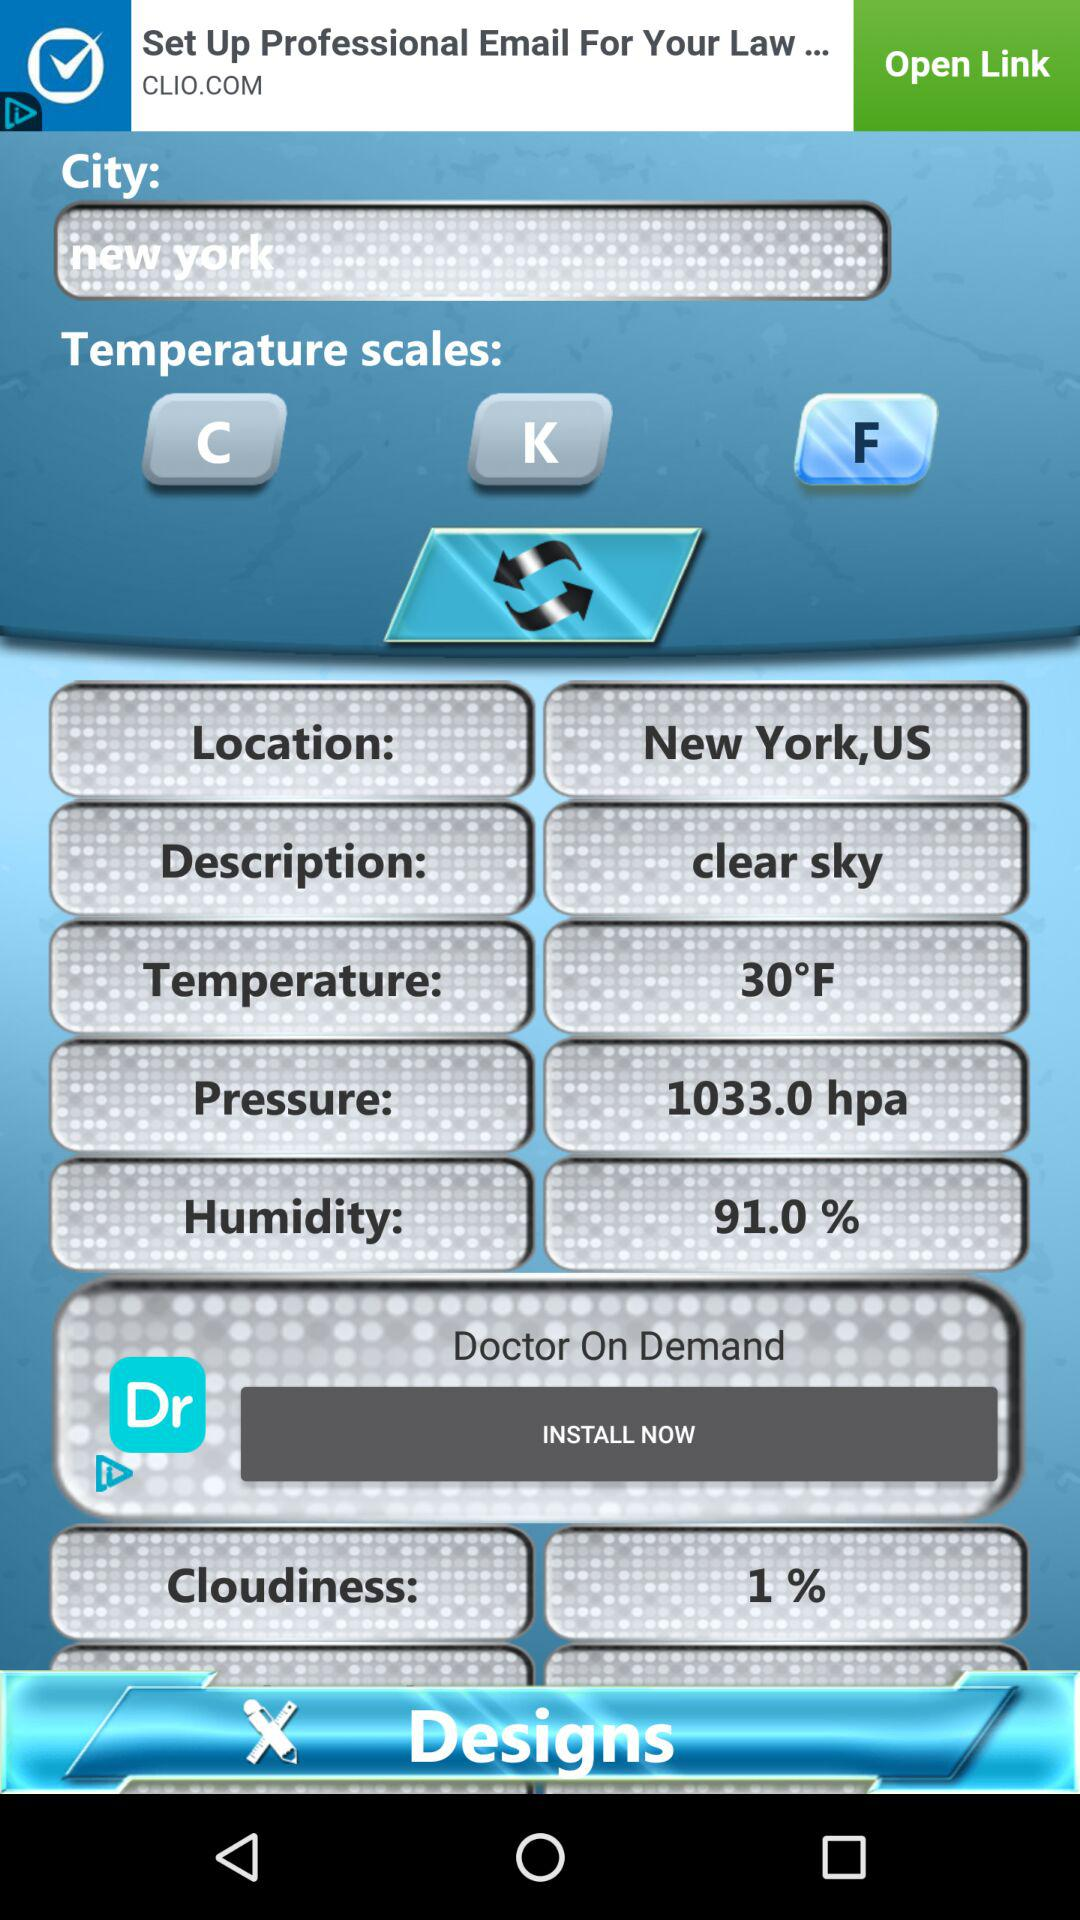Which city is mentioned? The mentioned city is New York. 